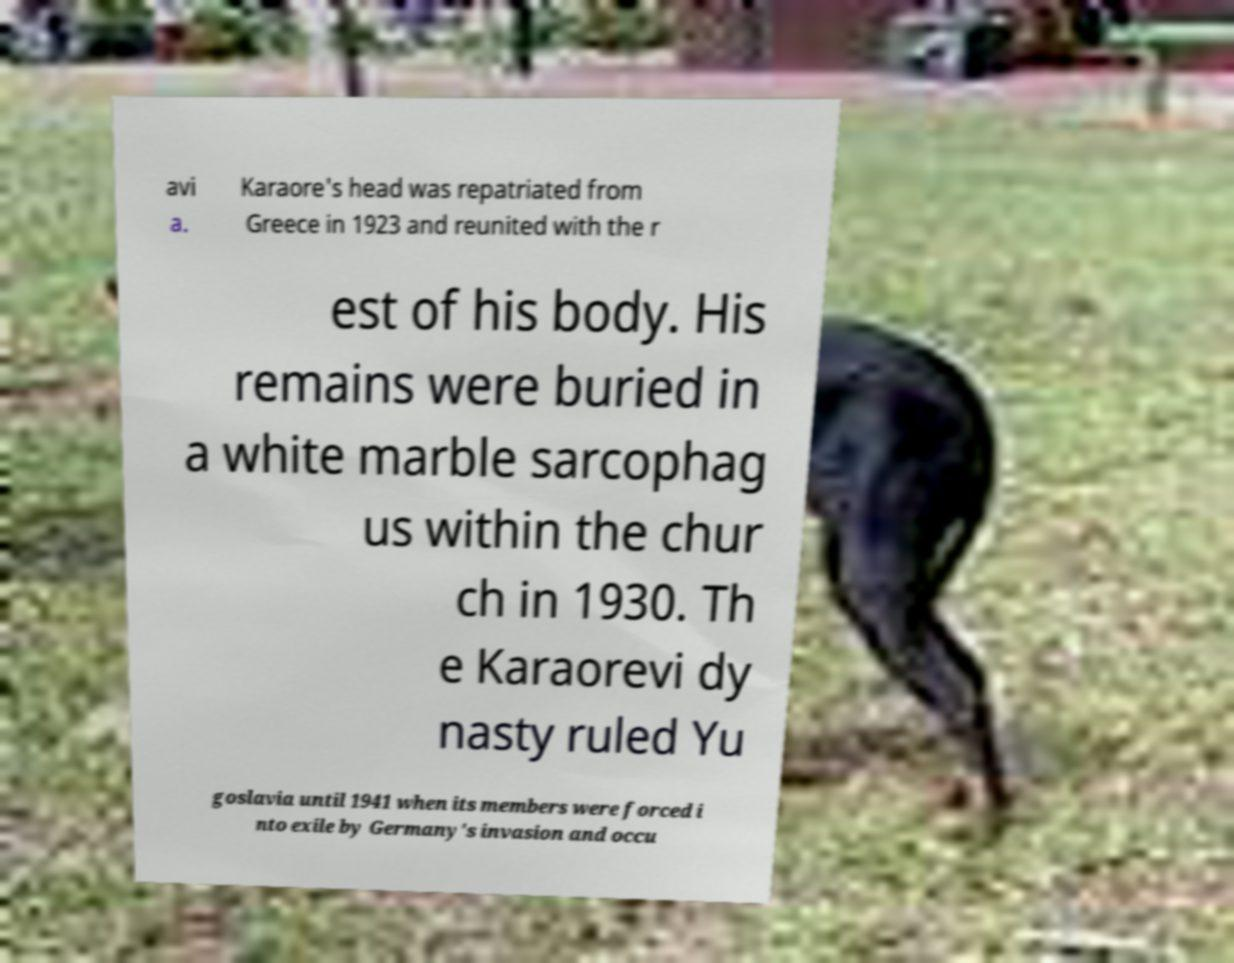Can you read and provide the text displayed in the image?This photo seems to have some interesting text. Can you extract and type it out for me? avi a. Karaore's head was repatriated from Greece in 1923 and reunited with the r est of his body. His remains were buried in a white marble sarcophag us within the chur ch in 1930. Th e Karaorevi dy nasty ruled Yu goslavia until 1941 when its members were forced i nto exile by Germany's invasion and occu 